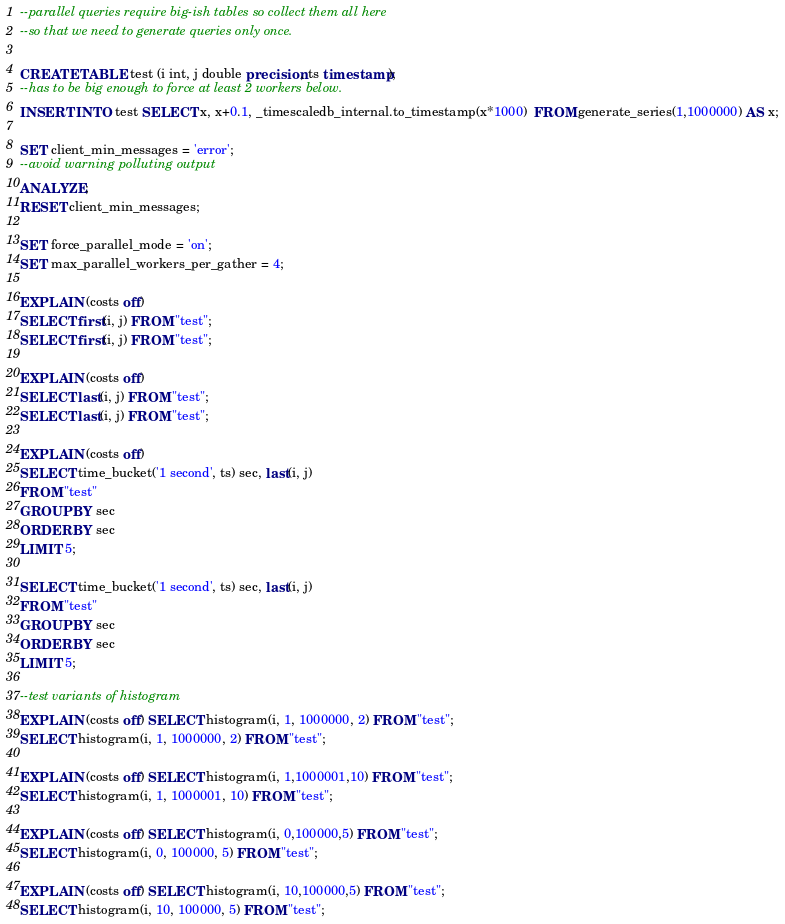<code> <loc_0><loc_0><loc_500><loc_500><_SQL_>--parallel queries require big-ish tables so collect them all here
--so that we need to generate queries only once.

CREATE TABLE test (i int, j double precision, ts timestamp);
--has to be big enough to force at least 2 workers below.
INSERT INTO test SELECT x, x+0.1, _timescaledb_internal.to_timestamp(x*1000)  FROM generate_series(1,1000000) AS x;

SET client_min_messages = 'error';
--avoid warning polluting output
ANALYZE;
RESET client_min_messages;

SET force_parallel_mode = 'on';
SET max_parallel_workers_per_gather = 4;

EXPLAIN (costs off)
SELECT first(i, j) FROM "test";
SELECT first(i, j) FROM "test";

EXPLAIN (costs off)
SELECT last(i, j) FROM "test";
SELECT last(i, j) FROM "test";

EXPLAIN (costs off)
SELECT time_bucket('1 second', ts) sec, last(i, j)
FROM "test"
GROUP BY sec
ORDER BY sec
LIMIT 5;

SELECT time_bucket('1 second', ts) sec, last(i, j)
FROM "test"
GROUP BY sec
ORDER BY sec
LIMIT 5;

--test variants of histogram
EXPLAIN (costs off) SELECT histogram(i, 1, 1000000, 2) FROM "test";
SELECT histogram(i, 1, 1000000, 2) FROM "test";

EXPLAIN (costs off) SELECT histogram(i, 1,1000001,10) FROM "test";
SELECT histogram(i, 1, 1000001, 10) FROM "test";

EXPLAIN (costs off) SELECT histogram(i, 0,100000,5) FROM "test";
SELECT histogram(i, 0, 100000, 5) FROM "test";

EXPLAIN (costs off) SELECT histogram(i, 10,100000,5) FROM "test";
SELECT histogram(i, 10, 100000, 5) FROM "test";
</code> 